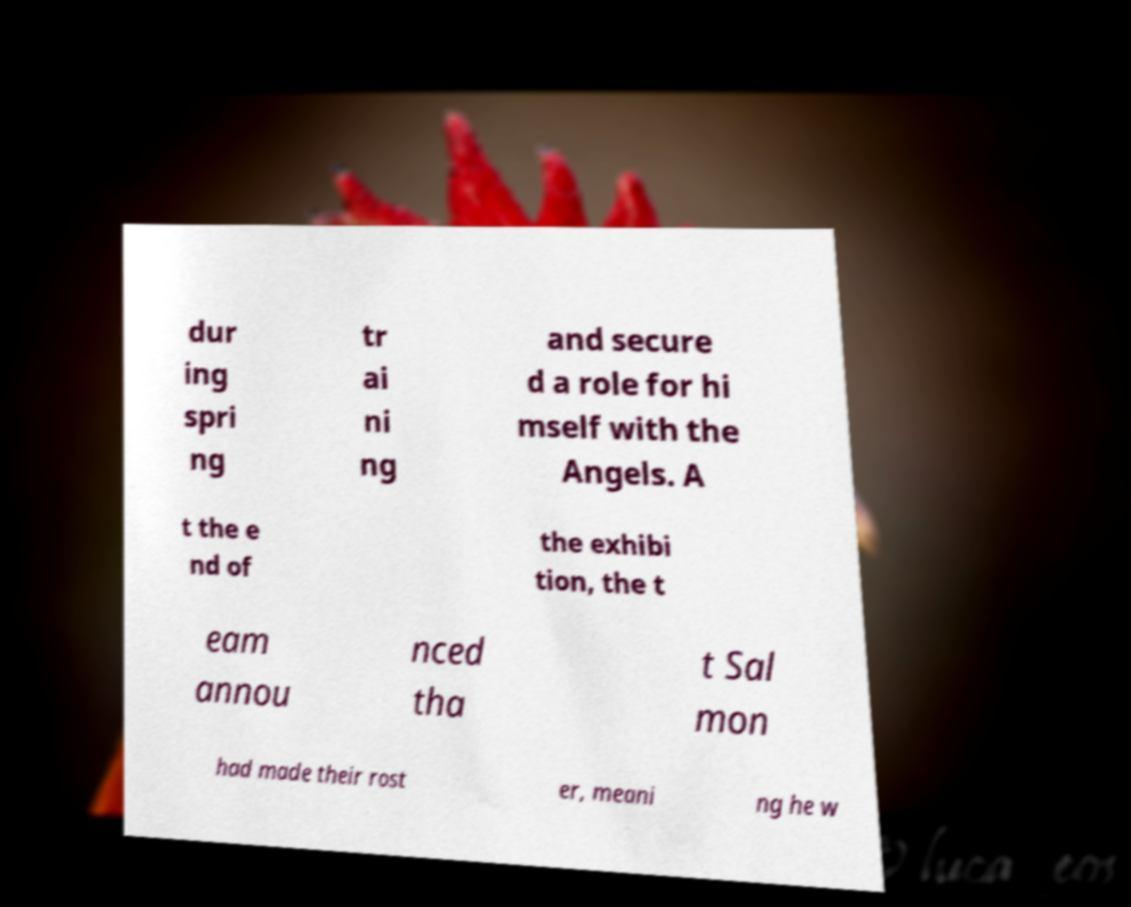Can you accurately transcribe the text from the provided image for me? dur ing spri ng tr ai ni ng and secure d a role for hi mself with the Angels. A t the e nd of the exhibi tion, the t eam annou nced tha t Sal mon had made their rost er, meani ng he w 